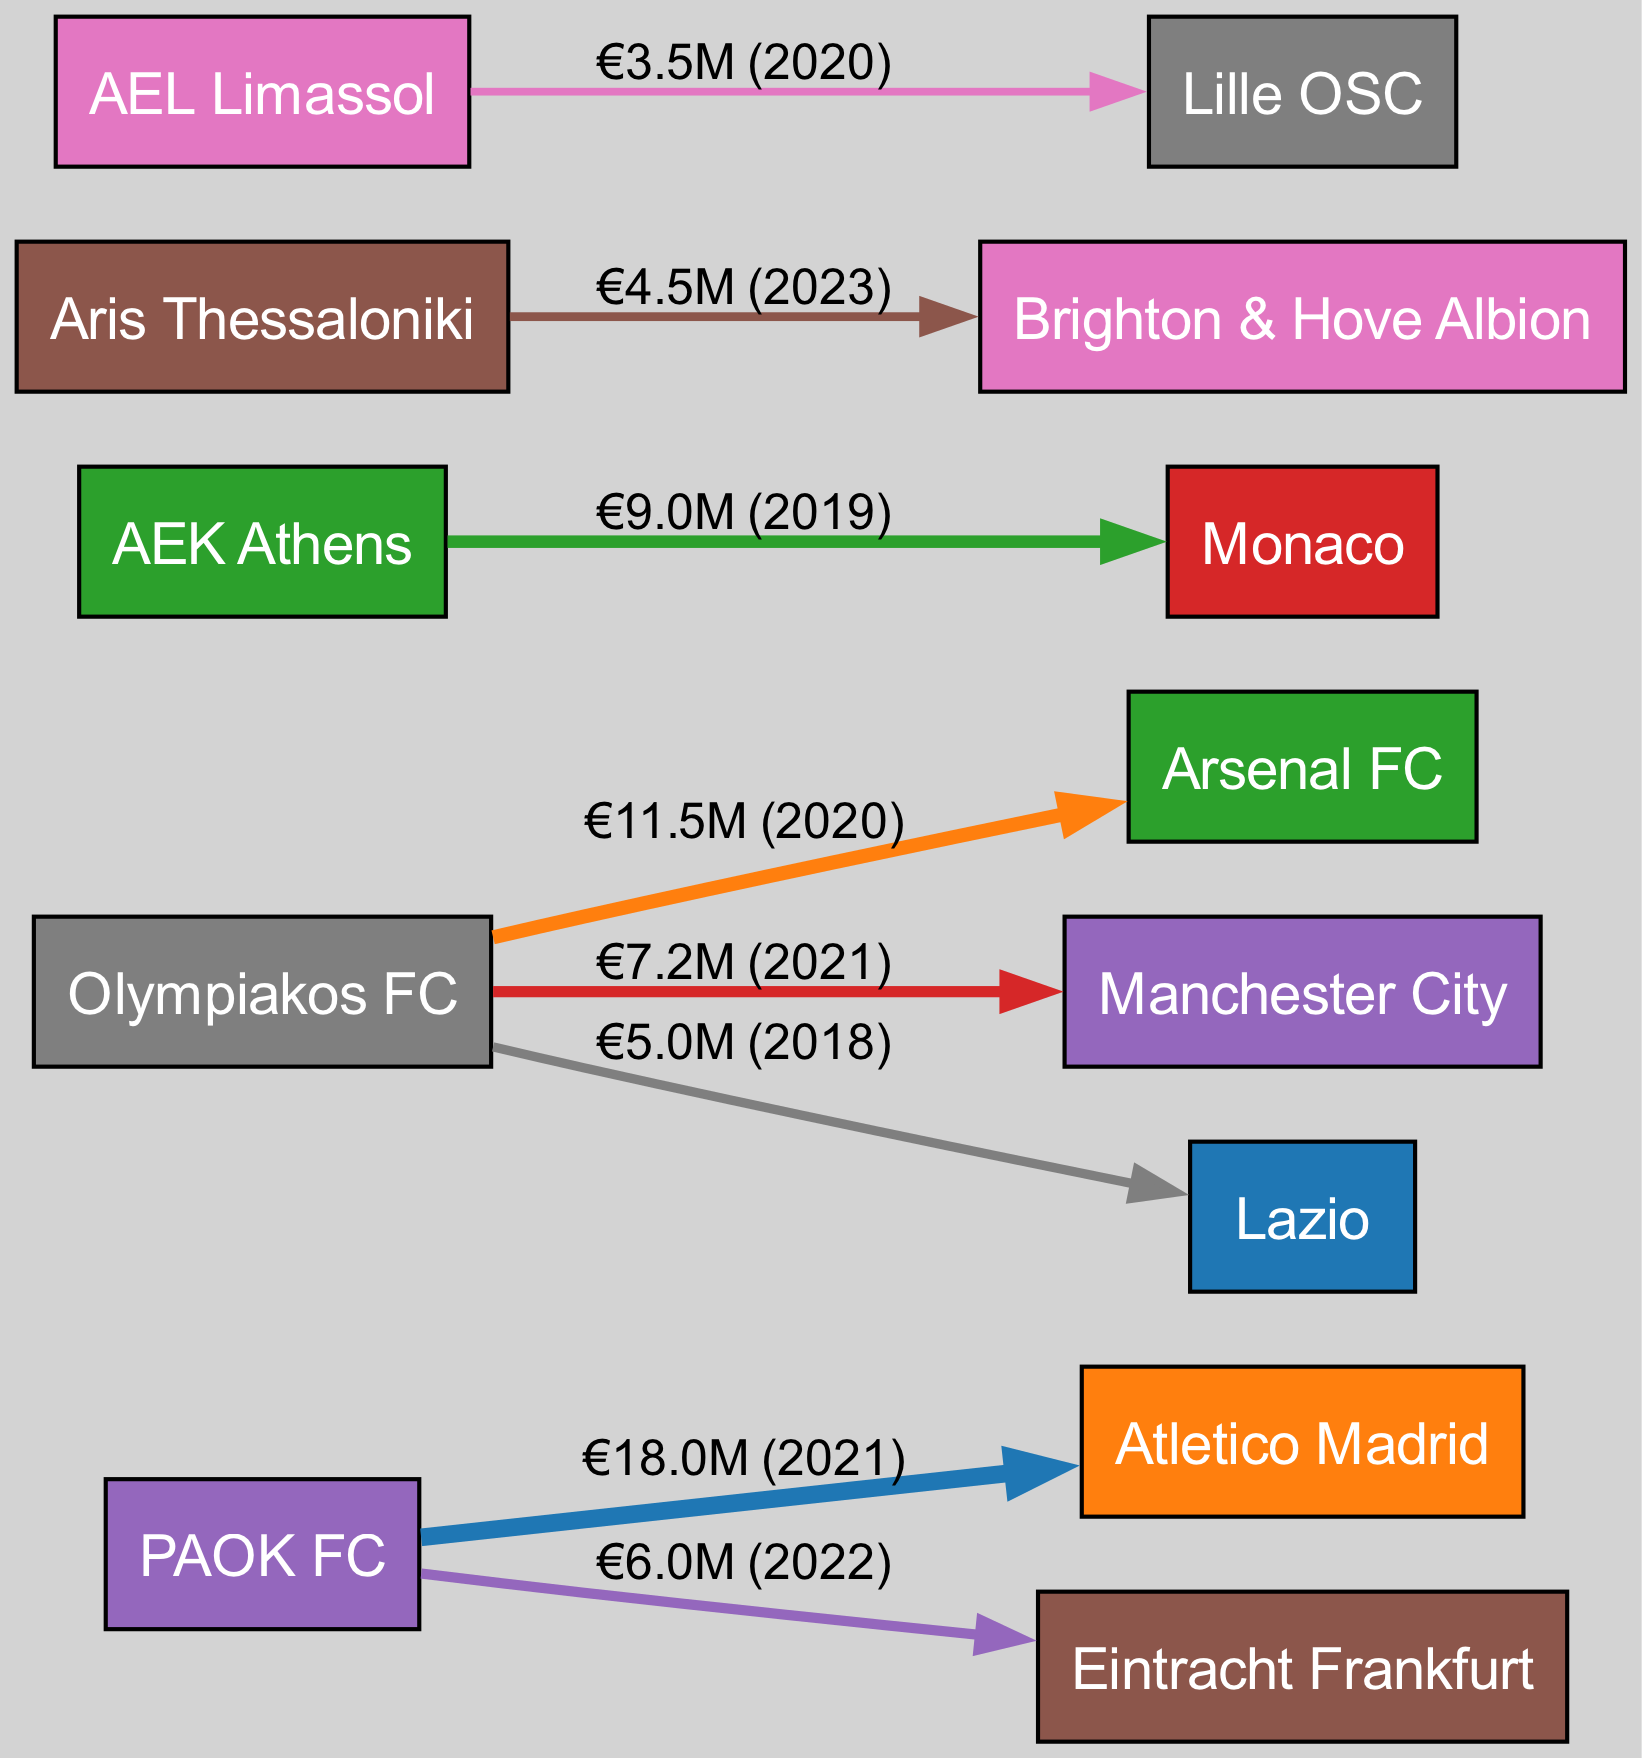What is the highest transfer amount in the diagram? By examining all the transfer amounts listed, the highest value is €18M from PAOK FC to Atletico Madrid in 2021.
Answer: €18M Which club transferred a player to Lazio? The diagram shows that Olympiakos FC transferred a player to Lazio for €5M in 2018.
Answer: Olympiakos FC How many clubs are represented as sources in the transfers? Counting the unique source clubs mentioned in the transfers, there are five: PAOK FC, Olympiakos FC, AEK Athens, Aris Thessaloniki, and AEL Limassol.
Answer: 5 What was the total transfer flow from Olympiakos FC? Summing the transfer amounts from Olympiakos FC, which are €11.5M to Arsenal FC, €7.2M to Manchester City, and €5M to Lazio, results in a total of €23.7M.
Answer: €23.7M Who was the recipient of the lowest transfer amount in the diagram? Looking at the directed edges from each source, the lowest transfer amount is €3.5M from AEL Limassol to Lille OSC in 2020.
Answer: Lille OSC How many transfers occurred in 2021? Based on the data, there are two transfers that took place in 2021: one from PAOK FC to Atletico Madrid and another from Olympiakos FC to Manchester City.
Answer: 2 What is the total number of transfers displayed in the diagram? By counting each entry in the data, there are a total of eight transfers represented in the diagram.
Answer: 8 Which year had more than one transfer and which clubs were involved? The year 2021 had two transfers: PAOK FC to Atletico Madrid and Olympiakos FC to Manchester City.
Answer: 2021, PAOK FC, Olympiakos FC Which club received a transfer from Aris Thessaloniki? According to the diagram, Aris Thessaloniki transferred a player to Brighton & Hove Albion for €4.5M in 2023.
Answer: Brighton & Hove Albion 